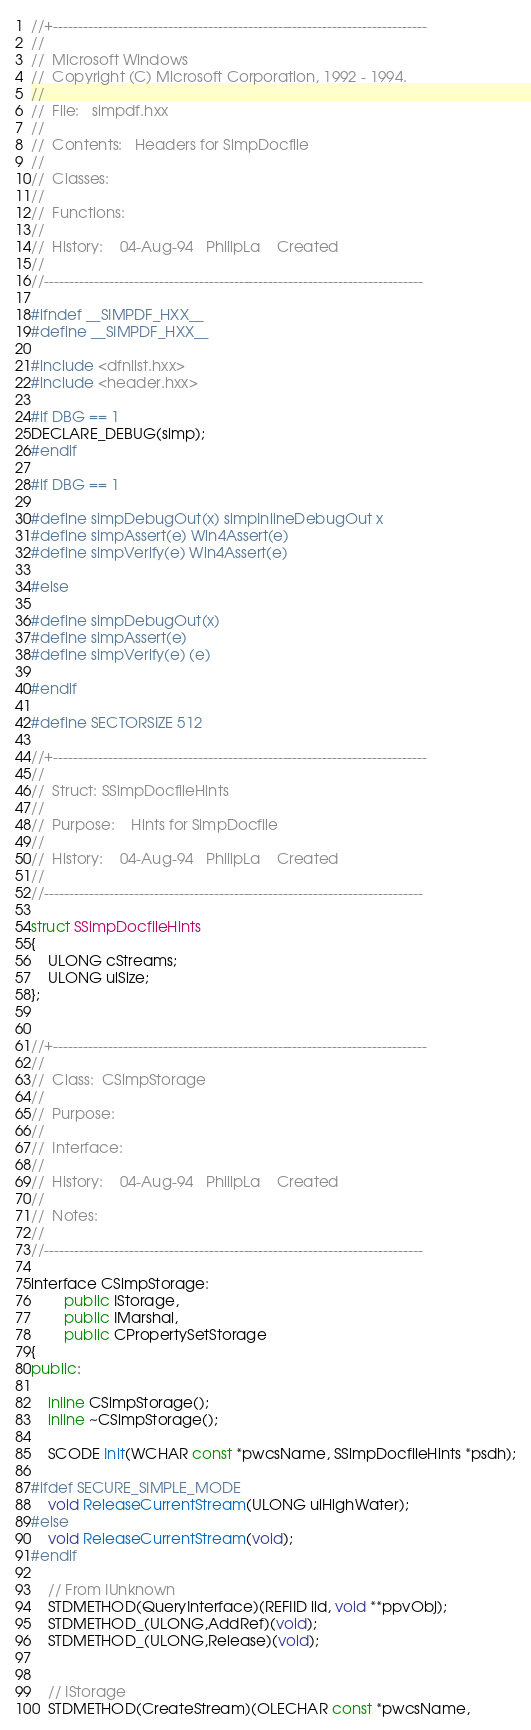Convert code to text. <code><loc_0><loc_0><loc_500><loc_500><_C++_>//+---------------------------------------------------------------------------
//
//  Microsoft Windows
//  Copyright (C) Microsoft Corporation, 1992 - 1994.
//
//  File:	simpdf.hxx
//
//  Contents:	Headers for SimpDocfile
//
//  Classes:	
//
//  Functions:	
//
//  History:	04-Aug-94	PhilipLa	Created
//
//----------------------------------------------------------------------------

#ifndef __SIMPDF_HXX__
#define __SIMPDF_HXX__

#include <dfnlist.hxx>
#include <header.hxx>

#if DBG == 1
DECLARE_DEBUG(simp);
#endif

#if DBG == 1

#define simpDebugOut(x) simpInlineDebugOut x
#define simpAssert(e) Win4Assert(e)
#define simpVerify(e) Win4Assert(e)

#else

#define simpDebugOut(x)
#define simpAssert(e)
#define simpVerify(e) (e)

#endif

#define SECTORSIZE 512

//+---------------------------------------------------------------------------
//
//  Struct:	SSimpDocfileHints
//
//  Purpose:	Hints for SimpDocfile
//
//  History:	04-Aug-94	PhilipLa	Created
//
//----------------------------------------------------------------------------

struct SSimpDocfileHints
{
    ULONG cStreams;
    ULONG ulSize;
};


//+---------------------------------------------------------------------------
//
//  Class:	CSimpStorage
//
//  Purpose:	
//
//  Interface:	
//
//  History:	04-Aug-94	PhilipLa	Created
//
//  Notes:	
//
//----------------------------------------------------------------------------

interface CSimpStorage:
        public IStorage,
        public IMarshal,
        public CPropertySetStorage
{
public:
    
    inline CSimpStorage();
    inline ~CSimpStorage();
    
    SCODE Init(WCHAR const *pwcsName, SSimpDocfileHints *psdh);

#ifdef SECURE_SIMPLE_MODE
    void ReleaseCurrentStream(ULONG ulHighWater);
#else
    void ReleaseCurrentStream(void);
#endif    
    
    // From IUnknown
    STDMETHOD(QueryInterface)(REFIID iid, void **ppvObj);
    STDMETHOD_(ULONG,AddRef)(void);
    STDMETHOD_(ULONG,Release)(void);


    // IStorage
    STDMETHOD(CreateStream)(OLECHAR const *pwcsName,</code> 